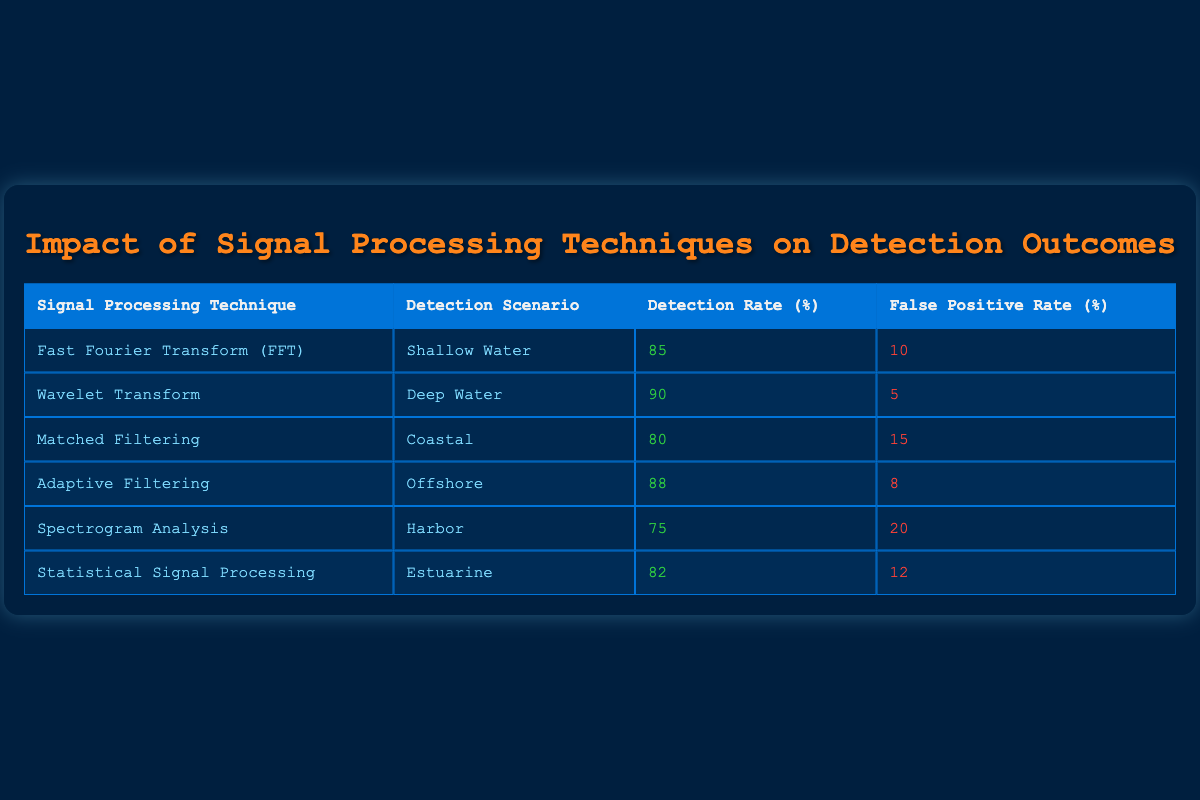What is the detection rate for Wavelet Transform? The table lists the detection rates for various signal processing techniques. For Wavelet Transform, the corresponding detection rate is explicitly stated as 90.
Answer: 90 Which signal processing technique has the highest false positive rate? By examining the table, I see the false positive rates for different techniques; Spectrogram Analysis has the highest at 20.
Answer: 20 What is the average detection rate across all techniques? To find the average detection rate, I sum the detection rates: (85 + 90 + 80 + 88 + 75 + 82) = 510. There are 6 techniques, so the average is 510/6 = 85.
Answer: 85 Is the false positive rate for Adaptive Filtering lower than 10%? The table shows that the false positive rate for Adaptive Filtering is 8, which is indeed lower than 10.
Answer: Yes Which detection scenario corresponds to the lowest detection rate? Looking through the detection rates listed, Spectrogram Analysis has the lowest detection rate of 75, associated with the Harbor scenario.
Answer: Harbor What is the difference in detection rates between Fast Fourier Transform and Matched Filtering? The detection rate for Fast Fourier Transform is 85, and for Matched Filtering, it is 80. The difference is 85 - 80 = 5.
Answer: 5 Are there more techniques with a detection rate above 85 than below? From the table, the techniques with detection rates above 85 are Wavelet Transform (90), Adaptive Filtering (88), and Fast Fourier Transform (85), which makes three. Below 85, we have Matched Filtering (80), Spectrogram Analysis (75), and Statistical Signal Processing (82), which totals three. Thus, there is an equal count.
Answer: No Which signal processing technique with a detection rate of more than 80 has the lowest false positive rate? The techniques with detection rates above 80 are Fast Fourier Transform (10), Wavelet Transform (5), Adaptive Filtering (8), and Statistical Signal Processing (12). Among these, Wavelet Transform has the lowest false positive rate of 5.
Answer: Wavelet Transform What is the sum of the false positive rates for detection scenarios in deep water and shallow water? In the table, the false positive rate for Wavelet Transform (Deep Water) is 5, and for Fast Fourier Transform (Shallow Water) is 10. Summing these gives 5 + 10 = 15.
Answer: 15 